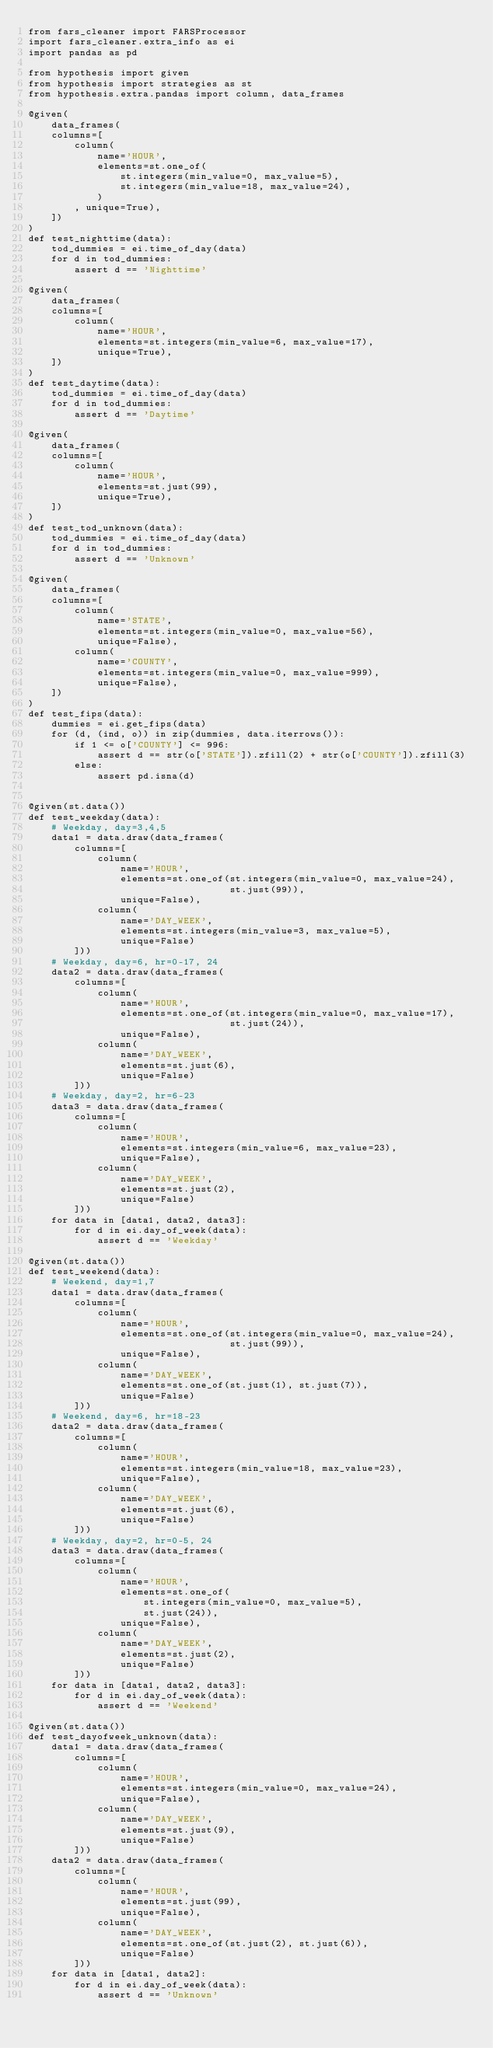Convert code to text. <code><loc_0><loc_0><loc_500><loc_500><_Python_>from fars_cleaner import FARSProcessor
import fars_cleaner.extra_info as ei
import pandas as pd

from hypothesis import given
from hypothesis import strategies as st
from hypothesis.extra.pandas import column, data_frames

@given(
    data_frames(
    columns=[
        column(
            name='HOUR',
            elements=st.one_of(
                st.integers(min_value=0, max_value=5),
                st.integers(min_value=18, max_value=24),
            )
        , unique=True),
    ])
)
def test_nighttime(data):
    tod_dummies = ei.time_of_day(data)
    for d in tod_dummies:
        assert d == 'Nighttime'

@given(
    data_frames(
    columns=[
        column(
            name='HOUR',
            elements=st.integers(min_value=6, max_value=17),
            unique=True),
    ])
)
def test_daytime(data):
    tod_dummies = ei.time_of_day(data)
    for d in tod_dummies:
        assert d == 'Daytime'

@given(
    data_frames(
    columns=[
        column(
            name='HOUR',
            elements=st.just(99),
            unique=True),
    ])
)
def test_tod_unknown(data):
    tod_dummies = ei.time_of_day(data)
    for d in tod_dummies:
        assert d == 'Unknown'

@given(
    data_frames(
    columns=[
        column(
            name='STATE',
            elements=st.integers(min_value=0, max_value=56),
            unique=False),
        column(
            name='COUNTY',
            elements=st.integers(min_value=0, max_value=999),
            unique=False),
    ])
)
def test_fips(data):
    dummies = ei.get_fips(data)
    for (d, (ind, o)) in zip(dummies, data.iterrows()):
        if 1 <= o['COUNTY'] <= 996:
            assert d == str(o['STATE']).zfill(2) + str(o['COUNTY']).zfill(3)
        else:
            assert pd.isna(d)


@given(st.data())
def test_weekday(data):
    # Weekday, day=3,4,5
    data1 = data.draw(data_frames(
        columns=[
            column(
                name='HOUR',
                elements=st.one_of(st.integers(min_value=0, max_value=24),
                                   st.just(99)),
                unique=False),
            column(
                name='DAY_WEEK',
                elements=st.integers(min_value=3, max_value=5),
                unique=False)
        ]))
    # Weekday, day=6, hr=0-17, 24
    data2 = data.draw(data_frames(
        columns=[
            column(
                name='HOUR',
                elements=st.one_of(st.integers(min_value=0, max_value=17),
                                   st.just(24)),
                unique=False),
            column(
                name='DAY_WEEK',
                elements=st.just(6),
                unique=False)
        ]))
    # Weekday, day=2, hr=6-23
    data3 = data.draw(data_frames(
        columns=[
            column(
                name='HOUR',
                elements=st.integers(min_value=6, max_value=23),
                unique=False),
            column(
                name='DAY_WEEK',
                elements=st.just(2),
                unique=False)
        ]))
    for data in [data1, data2, data3]:
        for d in ei.day_of_week(data):
            assert d == 'Weekday'

@given(st.data())
def test_weekend(data):
    # Weekend, day=1,7
    data1 = data.draw(data_frames(
        columns=[
            column(
                name='HOUR',
                elements=st.one_of(st.integers(min_value=0, max_value=24),
                                   st.just(99)),
                unique=False),
            column(
                name='DAY_WEEK',
                elements=st.one_of(st.just(1), st.just(7)),
                unique=False)
        ]))
    # Weekend, day=6, hr=18-23
    data2 = data.draw(data_frames(
        columns=[
            column(
                name='HOUR',
                elements=st.integers(min_value=18, max_value=23),
                unique=False),
            column(
                name='DAY_WEEK',
                elements=st.just(6),
                unique=False)
        ]))
    # Weekday, day=2, hr=0-5, 24
    data3 = data.draw(data_frames(
        columns=[
            column(
                name='HOUR',
                elements=st.one_of(
                    st.integers(min_value=0, max_value=5),
                    st.just(24)),
                unique=False),
            column(
                name='DAY_WEEK',
                elements=st.just(2),
                unique=False)
        ]))
    for data in [data1, data2, data3]:
        for d in ei.day_of_week(data):
            assert d == 'Weekend'

@given(st.data())
def test_dayofweek_unknown(data):
    data1 = data.draw(data_frames(
        columns=[
            column(
                name='HOUR',
                elements=st.integers(min_value=0, max_value=24),
                unique=False),
            column(
                name='DAY_WEEK',
                elements=st.just(9),
                unique=False)
        ]))
    data2 = data.draw(data_frames(
        columns=[
            column(
                name='HOUR',
                elements=st.just(99),
                unique=False),
            column(
                name='DAY_WEEK',
                elements=st.one_of(st.just(2), st.just(6)),
                unique=False)
        ]))
    for data in [data1, data2]:
        for d in ei.day_of_week(data):
            assert d == 'Unknown'

</code> 